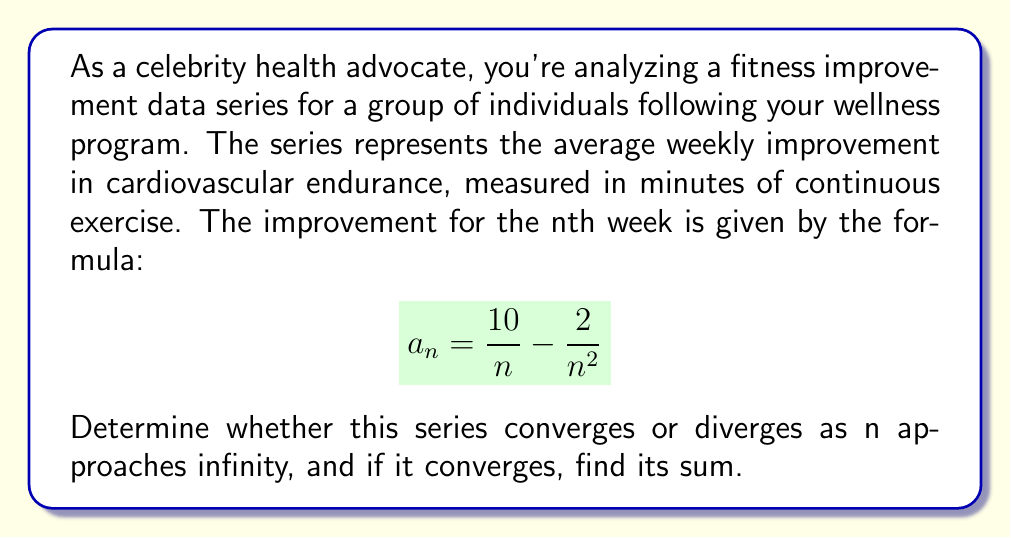Show me your answer to this math problem. To analyze the convergence of this series, we'll use the following steps:

1. First, let's examine the general term of the series:
   $$a_n = \frac{10}{n} - \frac{2}{n^2}$$

2. We can use the limit comparison test with the harmonic series $\frac{1}{n}$:
   $$\lim_{n \to \infty} \frac{a_n}{\frac{1}{n}} = \lim_{n \to \infty} \frac{\frac{10}{n} - \frac{2}{n^2}}{\frac{1}{n}}$$

3. Simplify:
   $$\lim_{n \to \infty} \left(10 - \frac{2}{n}\right) = 10$$

4. Since the limit is a non-zero finite value, our series converges if and only if the harmonic series converges. However, we know that the harmonic series diverges.

5. Therefore, our series $\sum_{n=1}^{\infty} (\frac{10}{n} - \frac{2}{n^2})$ also diverges.

6. We can interpret this result in the context of fitness improvement: The series diverging suggests that the total improvement over time is unbounded, indicating continuous long-term progress in cardiovascular endurance according to this model.
Answer: The series $\sum_{n=1}^{\infty} (\frac{10}{n} - \frac{2}{n^2})$ diverges. 